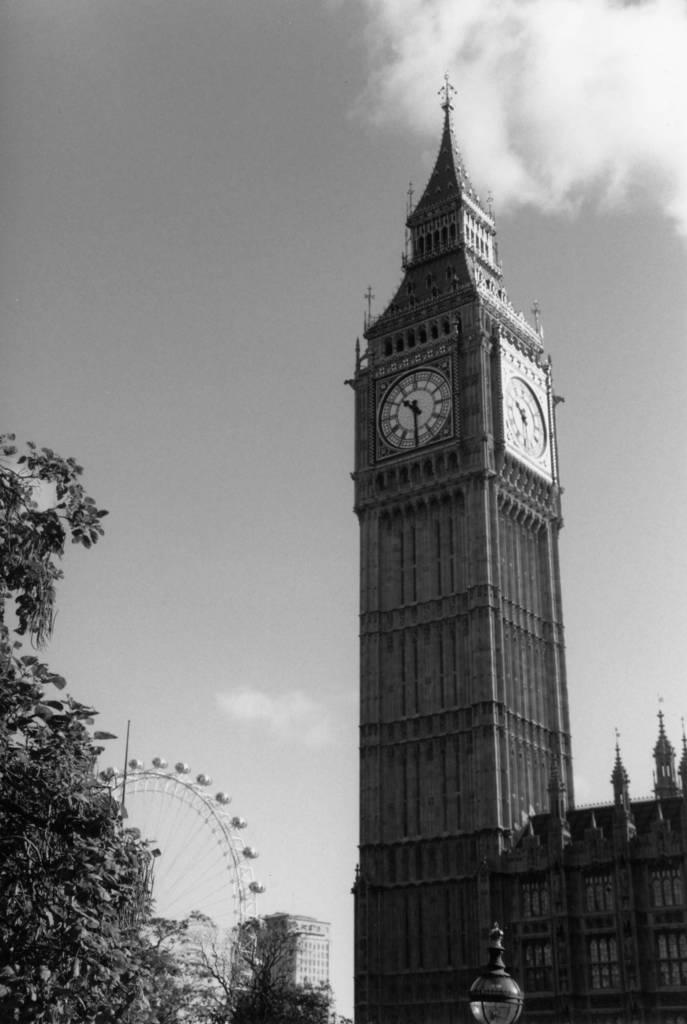What type of objects are on the building in the image? There are clocks on the building in the image. What can be seen illuminated in the image? There are lights visible in the image. What type of vegetation is present in the image? There are trees in the image. What type of amusement ride is in the image? There is a giant wheel in the image. What page of the book is the stranger reading in the image? There is no book or stranger present in the image. What invention is being used by the stranger in the image? There is no stranger or invention present in the image. 